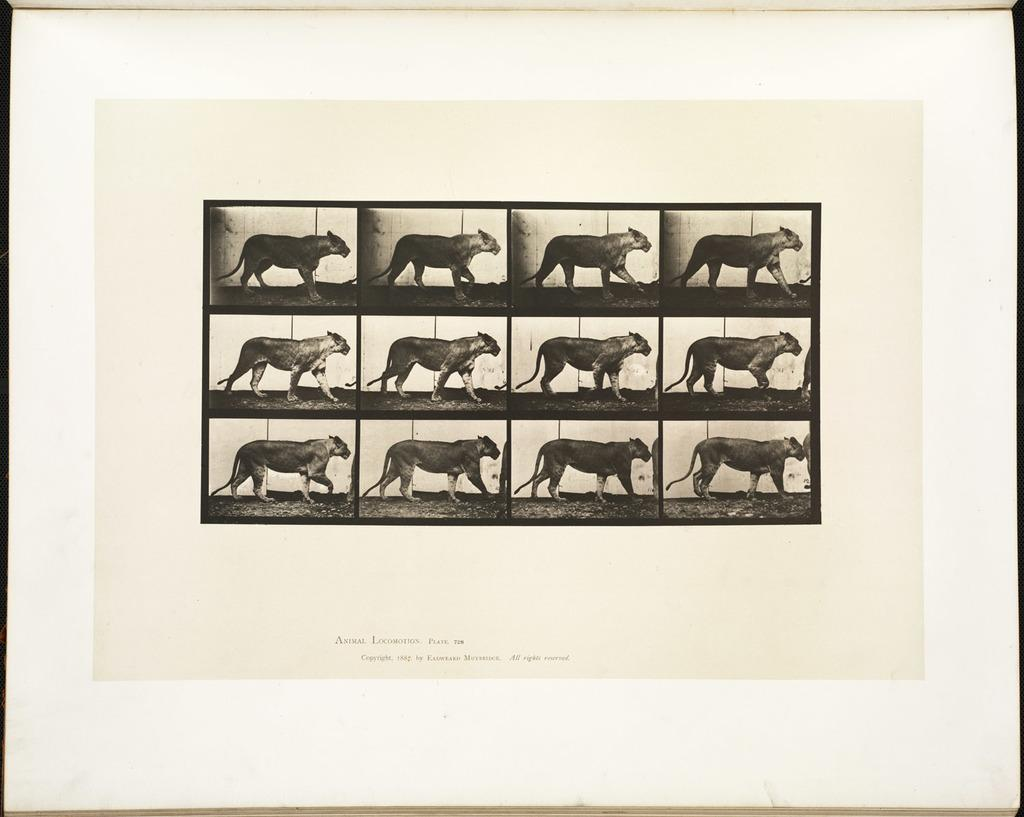What type of images can be seen on the paper? There are images of animals on the paper. What else can be found on the paper besides the animal images? There is writing on the paper. What color is the jar on the desk in the image? There is no jar or desk present in the image; it only features a paper with animal images and writing. 